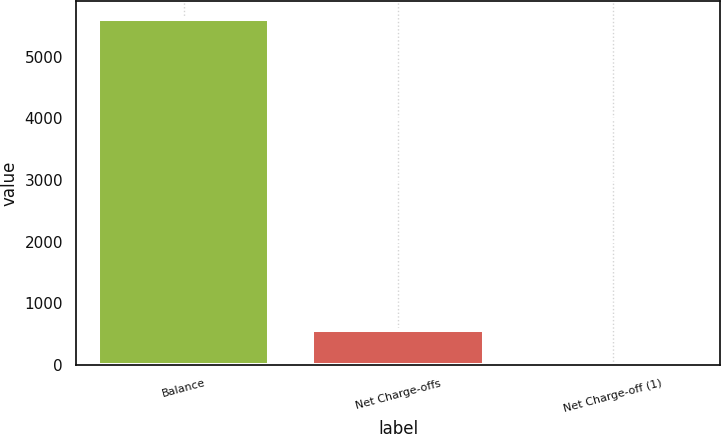Convert chart. <chart><loc_0><loc_0><loc_500><loc_500><bar_chart><fcel>Balance<fcel>Net Charge-offs<fcel>Net Charge-off (1)<nl><fcel>5622<fcel>563.17<fcel>1.08<nl></chart> 